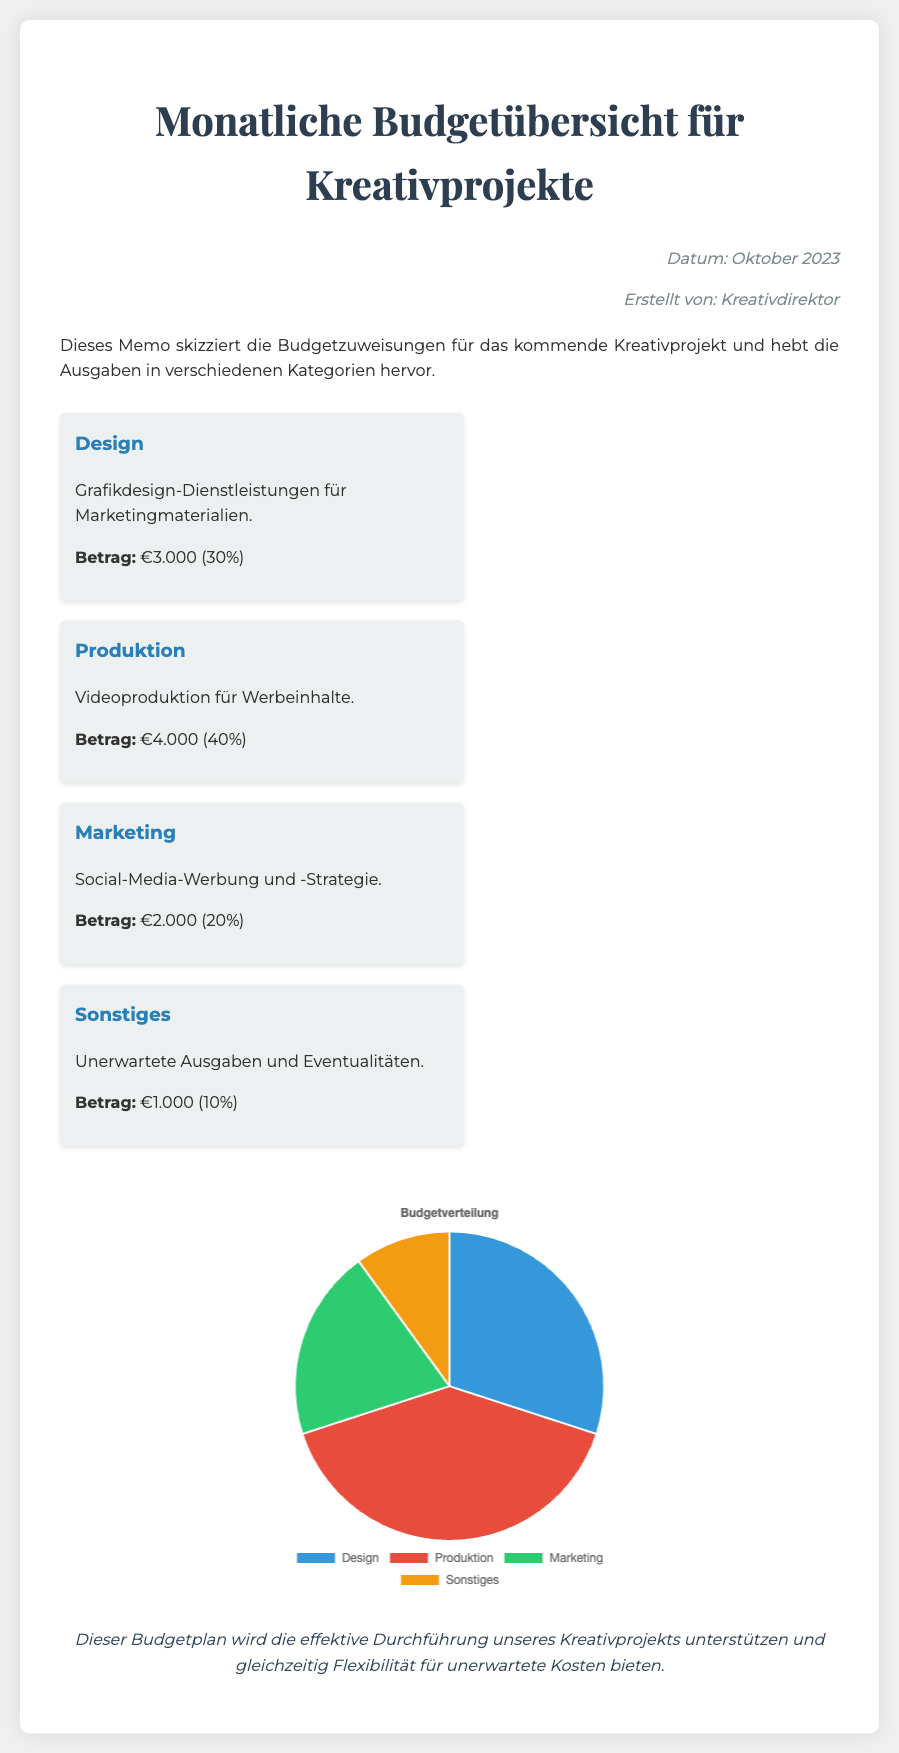Wie hoch ist das Budget für das Design? Das Budget für das Design beträgt €3.000.
Answer: €3.000 Was ist der Hauptzweck der Produktionsausgaben? Die Produktionsausgaben sind für Videoproduktion für Werbeinhalte.
Answer: Videoproduktion für Werbeinhalte Welcher Prozentsatz des Budgets ist für Marketing vorgesehen? Der Prozentsatz des Budgets für Marketing ist 20%.
Answer: 20% Wie viel beträgt der Betrag für sonstige Ausgaben? Der Betrag für sonstige Ausgaben beträgt €1.000.
Answer: €1.000 Welches ist die größte Budgetkategorie? Die größte Budgetkategorie ist die Produktion mit 40%.
Answer: Produktion mit 40% Wie viele Kategorien sind im Budgetübersicht aufgeführt? Es sind vier Kategorien im Budgetübersicht aufgeführt.
Answer: vier Wer hat das Memo erstellt? Das Memo wurde vom Kreativdirektor erstellt.
Answer: Kreativdirektor Was zeigt das Diagramm in der Budgetübersicht? Das Diagramm zeigt die Budgetverteilung in verschiedenen Kategorien.
Answer: Budgetverteilung in verschiedenen Kategorien Was ist die Aussage des Schlussfolgerungstextes? Der Schlussfolgerungstext hebt hervor, dass der Budgetplan die effektive Durchführung des Projekts unterstützt.
Answer: Unterstützt die effektive Durchführung des Projekts 